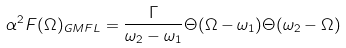<formula> <loc_0><loc_0><loc_500><loc_500>\alpha ^ { 2 } F ( \Omega ) _ { G M F L } = \frac { \Gamma } { \omega _ { 2 } - \omega _ { 1 } } \Theta ( \Omega - \omega _ { 1 } ) \Theta ( \omega _ { 2 } - \Omega )</formula> 